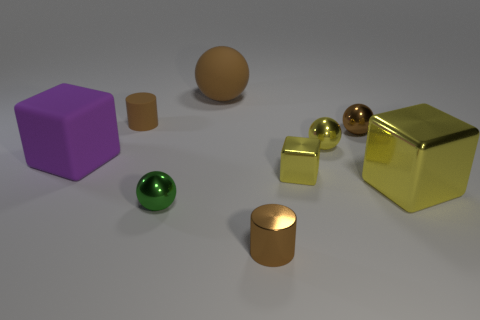Subtract all red blocks. How many brown balls are left? 2 Subtract all yellow balls. How many balls are left? 3 Subtract all matte spheres. How many spheres are left? 3 Subtract all gray cubes. Subtract all yellow cylinders. How many cubes are left? 3 Subtract all balls. How many objects are left? 5 Subtract 0 red spheres. How many objects are left? 9 Subtract all yellow metallic things. Subtract all purple shiny cylinders. How many objects are left? 6 Add 2 small brown rubber cylinders. How many small brown rubber cylinders are left? 3 Add 7 small brown cylinders. How many small brown cylinders exist? 9 